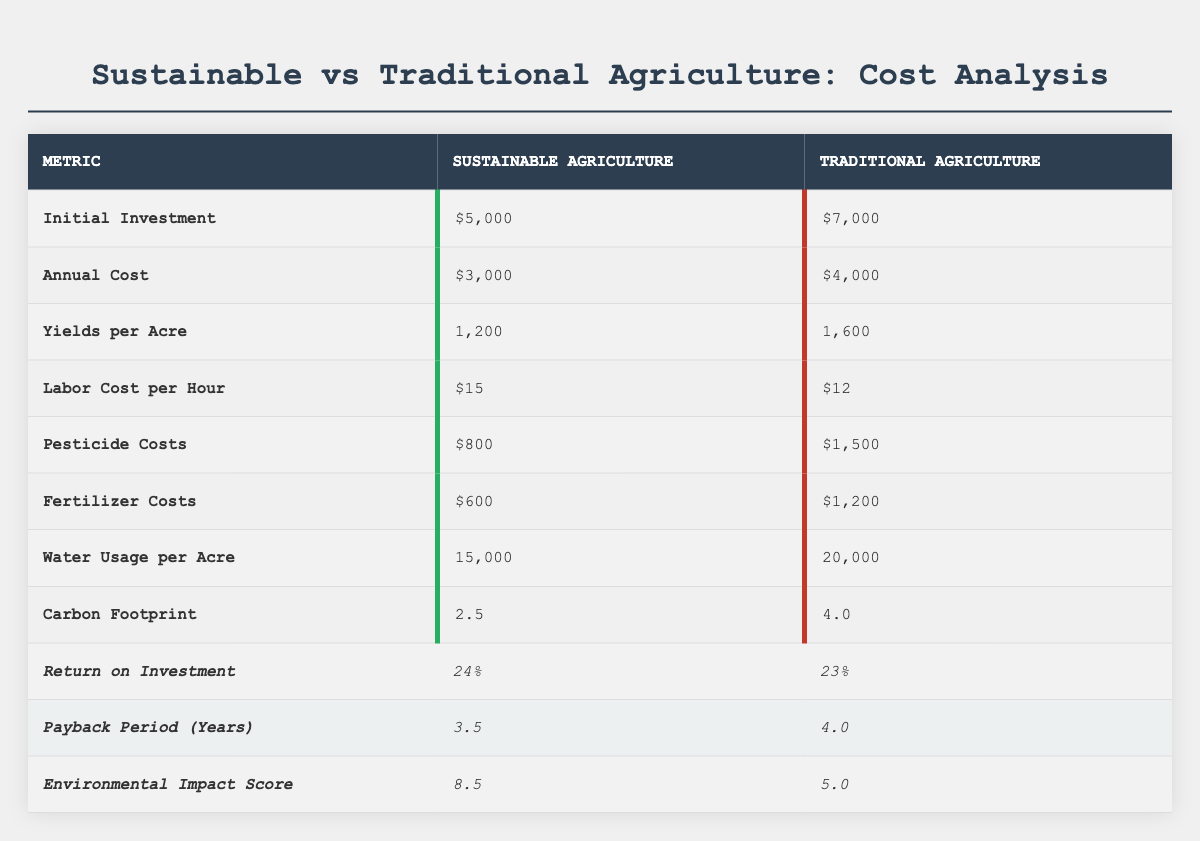What is the initial investment for sustainable agriculture? The table lists the initial investment for sustainable agriculture as $5,000.
Answer: $5,000 What are the annual costs for traditional agriculture? According to the table, the annual cost for traditional agriculture is $4,000.
Answer: $4,000 Which practice has a higher yield per acre? The table shows that traditional agriculture has a yield of 1,600 per acre, while sustainable agriculture has a yield of 1,200 per acre. Thus, traditional agriculture has a higher yield.
Answer: Traditional agriculture What is the difference in pesticide costs between the two practices? The pesticide costs for sustainable agriculture are $800, while for traditional agriculture, they are $1,500. The difference is calculated as $1,500 - $800 = $700.
Answer: $700 What is the total labor cost per hour for both agricultural practices? The labor cost per hour for sustainable agriculture is $15 and for traditional agriculture, it's $12. Therefore, the total is $15 + $12 = $27.
Answer: $27 Which agricultural practice has a lower carbon footprint? Sustainable agriculture has a carbon footprint of 2.5, while traditional agriculture has a carbon footprint of 4.0. Since 2.5 is less than 4.0, sustainable agriculture has a lower carbon footprint.
Answer: Sustainable agriculture Is the environmental impact score for sustainable agriculture higher than for traditional agriculture? The environmental impact score for sustainable agriculture is 8.5, while for traditional agriculture it is 5.0. Since 8.5 is greater than 5.0, the statement is true.
Answer: Yes How much more is the initial investment for traditional agriculture compared to sustainable agriculture? The initial investment for traditional agriculture is $7,000, while for sustainable agriculture, it's $5,000. The difference is $7,000 - $5,000 = $2,000.
Answer: $2,000 What is the average annual cost of the two agricultural practices? The annual costs are $3,000 for sustainable agriculture and $4,000 for traditional agriculture. To find the average: (3,000 + 4,000) / 2 = $3,500.
Answer: $3,500 Which practice has a shorter payback period? The payback period for sustainable agriculture is 3.5 years, while for traditional agriculture it is 4.0 years. Therefore, sustainable agriculture has a shorter payback period.
Answer: Sustainable agriculture 